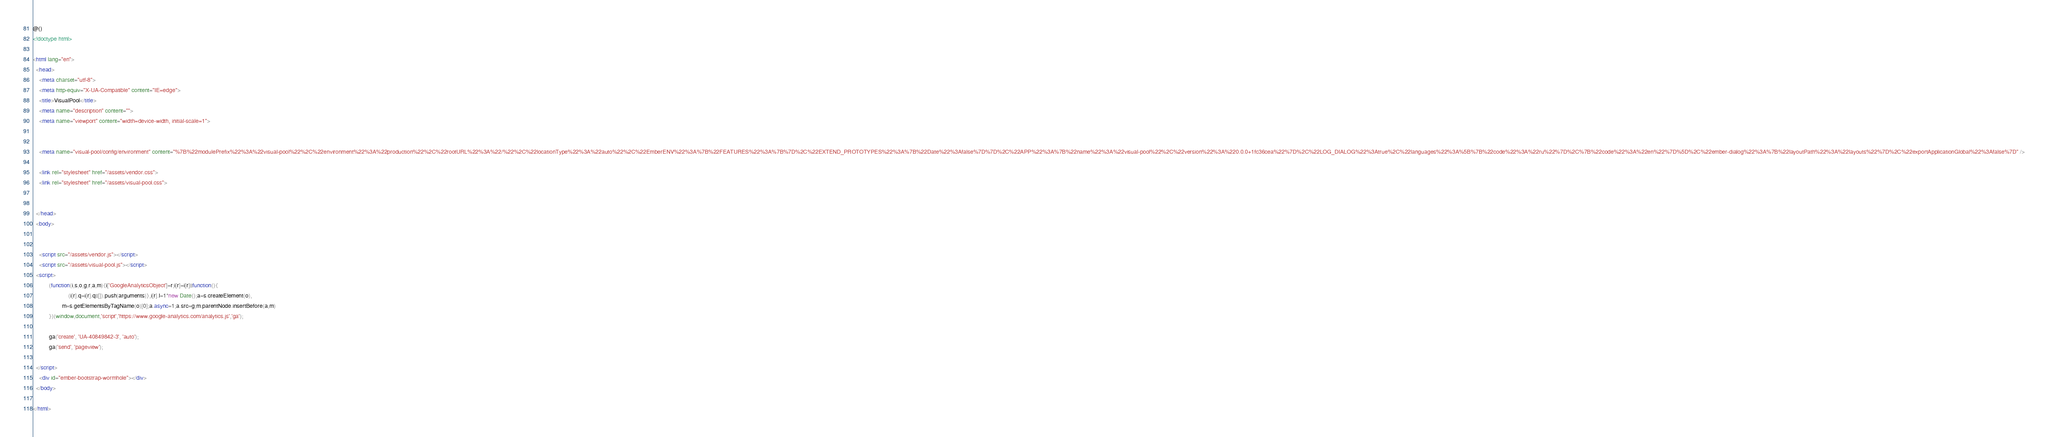Convert code to text. <code><loc_0><loc_0><loc_500><loc_500><_HTML_>@()
<!doctype html>

<html lang="en">
  <head>
    <meta charset="utf-8">
    <meta http-equiv="X-UA-Compatible" content="IE=edge">
    <title>VisualPool</title>
    <meta name="description" content="">
    <meta name="viewport" content="width=device-width, initial-scale=1">


    <meta name="visual-pool/config/environment" content="%7B%22modulePrefix%22%3A%22visual-pool%22%2C%22environment%22%3A%22production%22%2C%22rootURL%22%3A%22/%22%2C%22locationType%22%3A%22auto%22%2C%22EmberENV%22%3A%7B%22FEATURES%22%3A%7B%7D%2C%22EXTEND_PROTOTYPES%22%3A%7B%22Date%22%3Afalse%7D%7D%2C%22APP%22%3A%7B%22name%22%3A%22visual-pool%22%2C%22version%22%3A%220.0.0+1fc36cea%22%7D%2C%22LOG_DIALOG%22%3Atrue%2C%22languages%22%3A%5B%7B%22code%22%3A%22ru%22%7D%2C%7B%22code%22%3A%22en%22%7D%5D%2C%22ember-dialog%22%3A%7B%22layoutPath%22%3A%22layouts%22%7D%2C%22exportApplicationGlobal%22%3Afalse%7D" />

    <link rel="stylesheet" href="/assets/vendor.css">
    <link rel="stylesheet" href="/assets/visual-pool.css">


  </head>
  <body>


    <script src="/assets/vendor.js"></script>
    <script src="/assets/visual-pool.js"></script>
  <script>
          (function(i,s,o,g,r,a,m){i['GoogleAnalyticsObject']=r;i[r]=i[r]||function(){
                      (i[r].q=i[r].q||[]).push(arguments)},i[r].l=1*new Date();a=s.createElement(o),
                  m=s.getElementsByTagName(o)[0];a.async=1;a.src=g;m.parentNode.insertBefore(a,m)
          })(window,document,'script','https://www.google-analytics.com/analytics.js','ga');

          ga('create', 'UA-40849842-3', 'auto');
          ga('send', 'pageview');

  </script>
    <div id="ember-bootstrap-wormhole"></div>
  </body>

</html></code> 